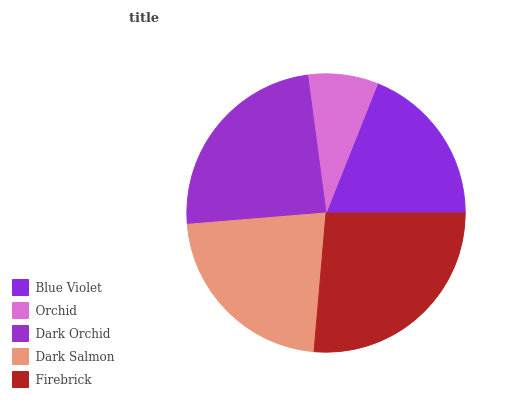Is Orchid the minimum?
Answer yes or no. Yes. Is Firebrick the maximum?
Answer yes or no. Yes. Is Dark Orchid the minimum?
Answer yes or no. No. Is Dark Orchid the maximum?
Answer yes or no. No. Is Dark Orchid greater than Orchid?
Answer yes or no. Yes. Is Orchid less than Dark Orchid?
Answer yes or no. Yes. Is Orchid greater than Dark Orchid?
Answer yes or no. No. Is Dark Orchid less than Orchid?
Answer yes or no. No. Is Dark Salmon the high median?
Answer yes or no. Yes. Is Dark Salmon the low median?
Answer yes or no. Yes. Is Firebrick the high median?
Answer yes or no. No. Is Orchid the low median?
Answer yes or no. No. 